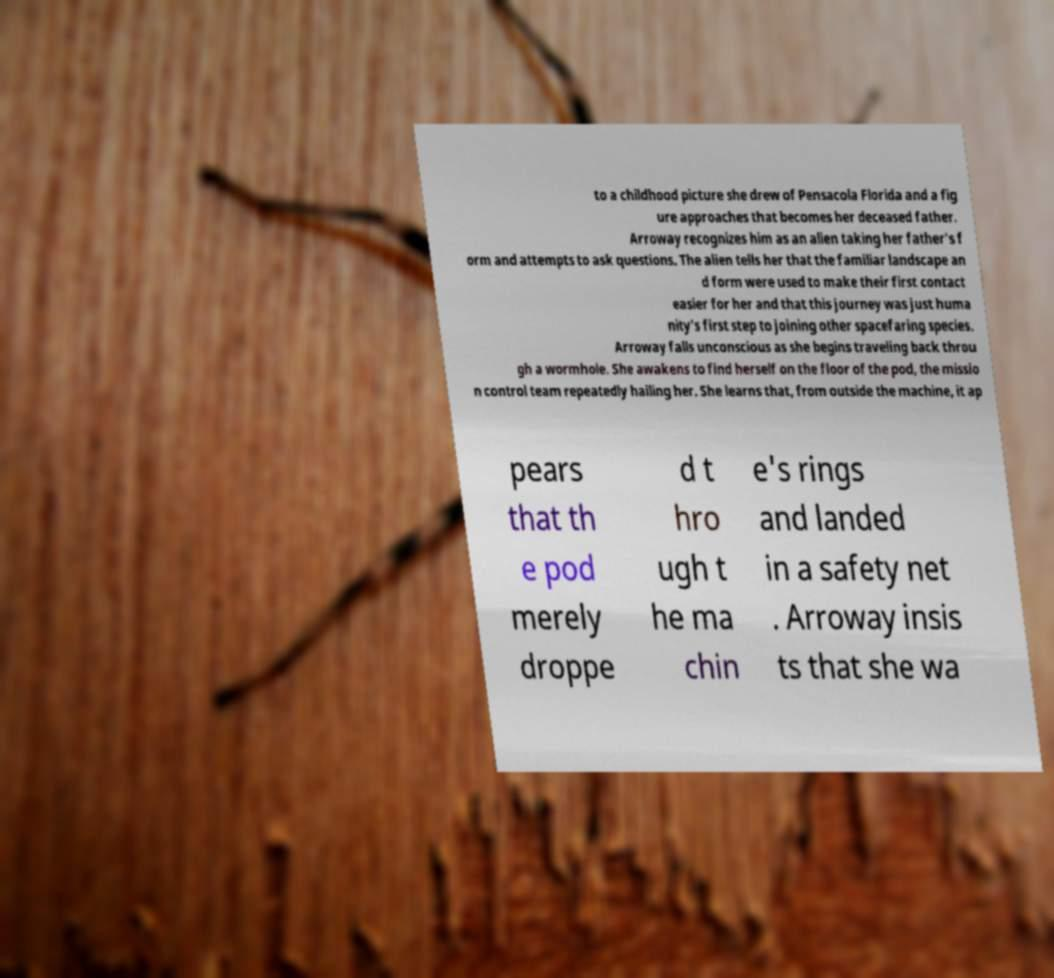Could you extract and type out the text from this image? to a childhood picture she drew of Pensacola Florida and a fig ure approaches that becomes her deceased father. Arroway recognizes him as an alien taking her father's f orm and attempts to ask questions. The alien tells her that the familiar landscape an d form were used to make their first contact easier for her and that this journey was just huma nity's first step to joining other spacefaring species. Arroway falls unconscious as she begins traveling back throu gh a wormhole. She awakens to find herself on the floor of the pod, the missio n control team repeatedly hailing her. She learns that, from outside the machine, it ap pears that th e pod merely droppe d t hro ugh t he ma chin e's rings and landed in a safety net . Arroway insis ts that she wa 